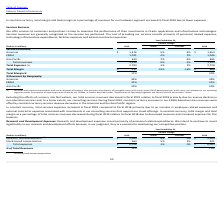Looking at Oracle Corporation's financial data, please calculate: By how much less did the company make in services revenues in 2019 compared to 2018? Based on the calculation: 3,395 - 3,240 , the result is 155 (in millions). This is based on the information: "Total revenues 3,240 -5% -2% 3,395 Total revenues 3,240 -5% -2% 3,395..." The key data points involved are: 3,240, 3,395. Also, can you calculate: How much less was the total margin in 2019 then in 2018? Based on the calculation: 666-537 , the result is 129 (in millions). This is based on the information: "Total Margin $ 537 -19% -18% $ 666 Total Margin $ 537 -19% -18% $ 666..." The key data points involved are: 537, 666. Also, can you calculate: What was the difference in percentage revenues by geography in the EMEA relative to the Asia Pacific in 2019? Based on the calculation: 31-20 , the result is 11 (in millions). This is based on the information: "(Dollars in millions) 2019 Actual Constant 2018 EMEA 31% 31%..." The key data points involved are: 20, 31. Also, How much was the constant percentage change and the actual percentage change in total expenses? The document shows two values: 2% and -1% (percentage). From the document: "Total Expenses (1) 2,703 -1% 2% 2,729 Total Expenses (1) 2,703 -1% 2% 2,729..." Also, What make up the company's cost of providing services? The cost of providing our services consists primarily of personnel related expenses, technology infrastructure expenditures, facilities expenses and external contractor expenses.. The document states: "enerally recognized as the services are performed. The cost of providing our services consists primarily of personnel related expenses, technology inf..." Also, Why did the total services revenue decrease in fiscal 2019 relative to fiscal 2018? Excluding the effects of currency rate fluctuations, our total services revenues decreased in fiscal 2019 relative to fiscal 2018 primarily due to revenue declines in our education services and, to a lesser extent, our consulting services.. The document states: "Excluding the effects of currency rate fluctuations, our total services revenues decreased in fiscal 2019 relative to fiscal 2018 primarily due to rev..." 